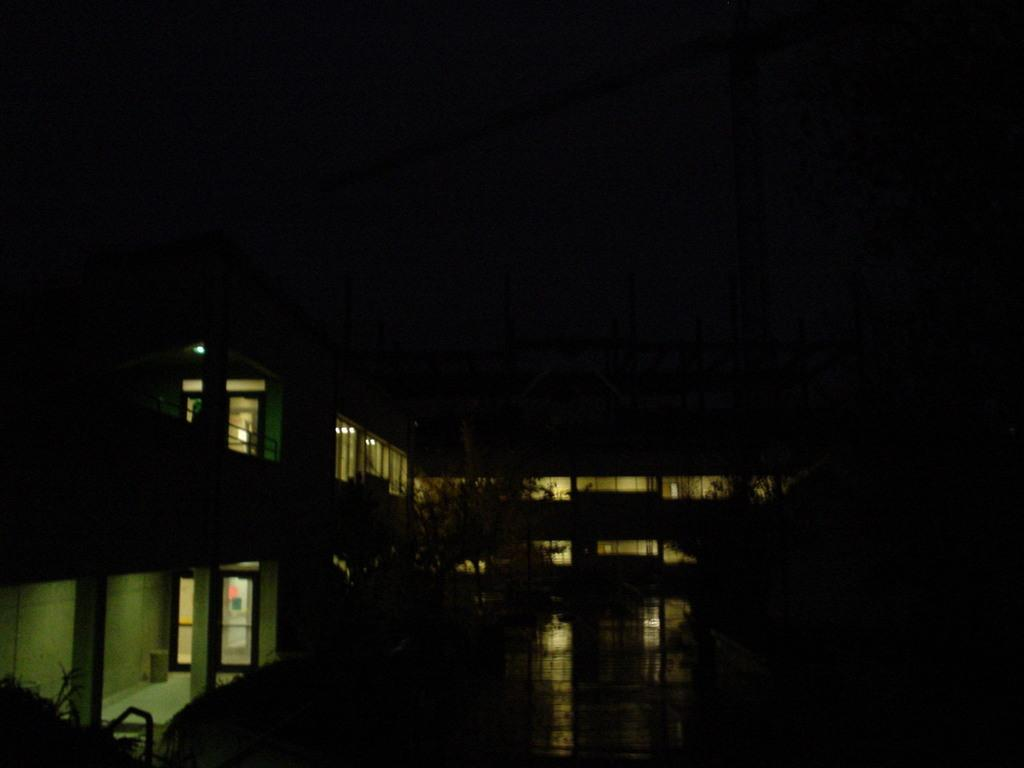What time of day was the image taken? The image was taken during night. What structures are visible in the image? There are buildings in the image. What type of vegetation is in front of the buildings? There are trees in front of the buildings in the image. What type of wave can be seen crashing on the shore in the image? There is no wave or shore present in the image; it features buildings and trees during nighttime. 